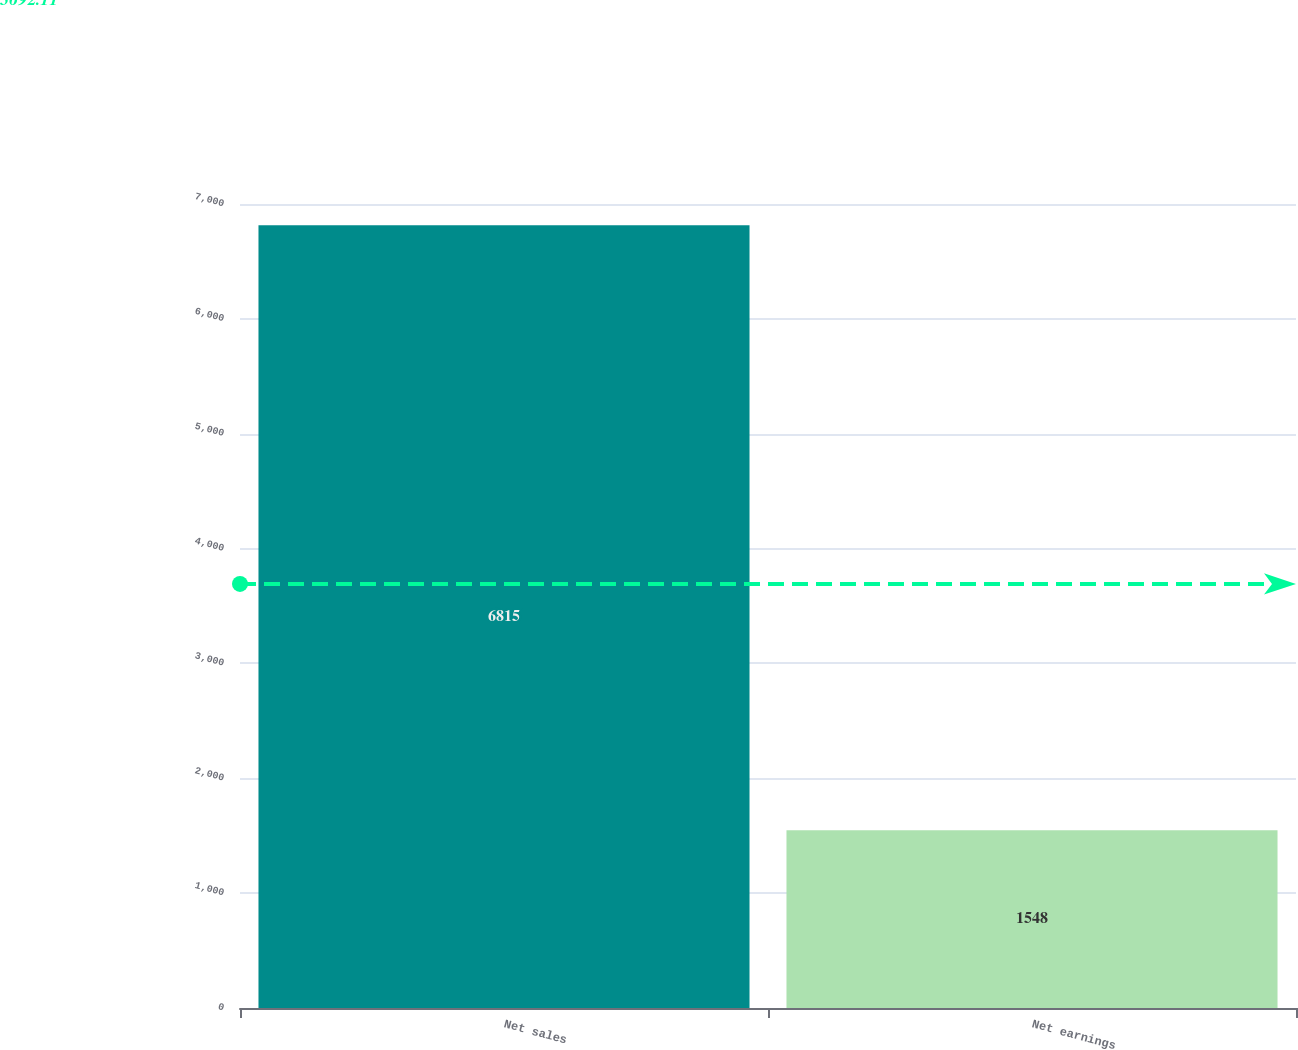Convert chart to OTSL. <chart><loc_0><loc_0><loc_500><loc_500><bar_chart><fcel>Net sales<fcel>Net earnings<nl><fcel>6815<fcel>1548<nl></chart> 